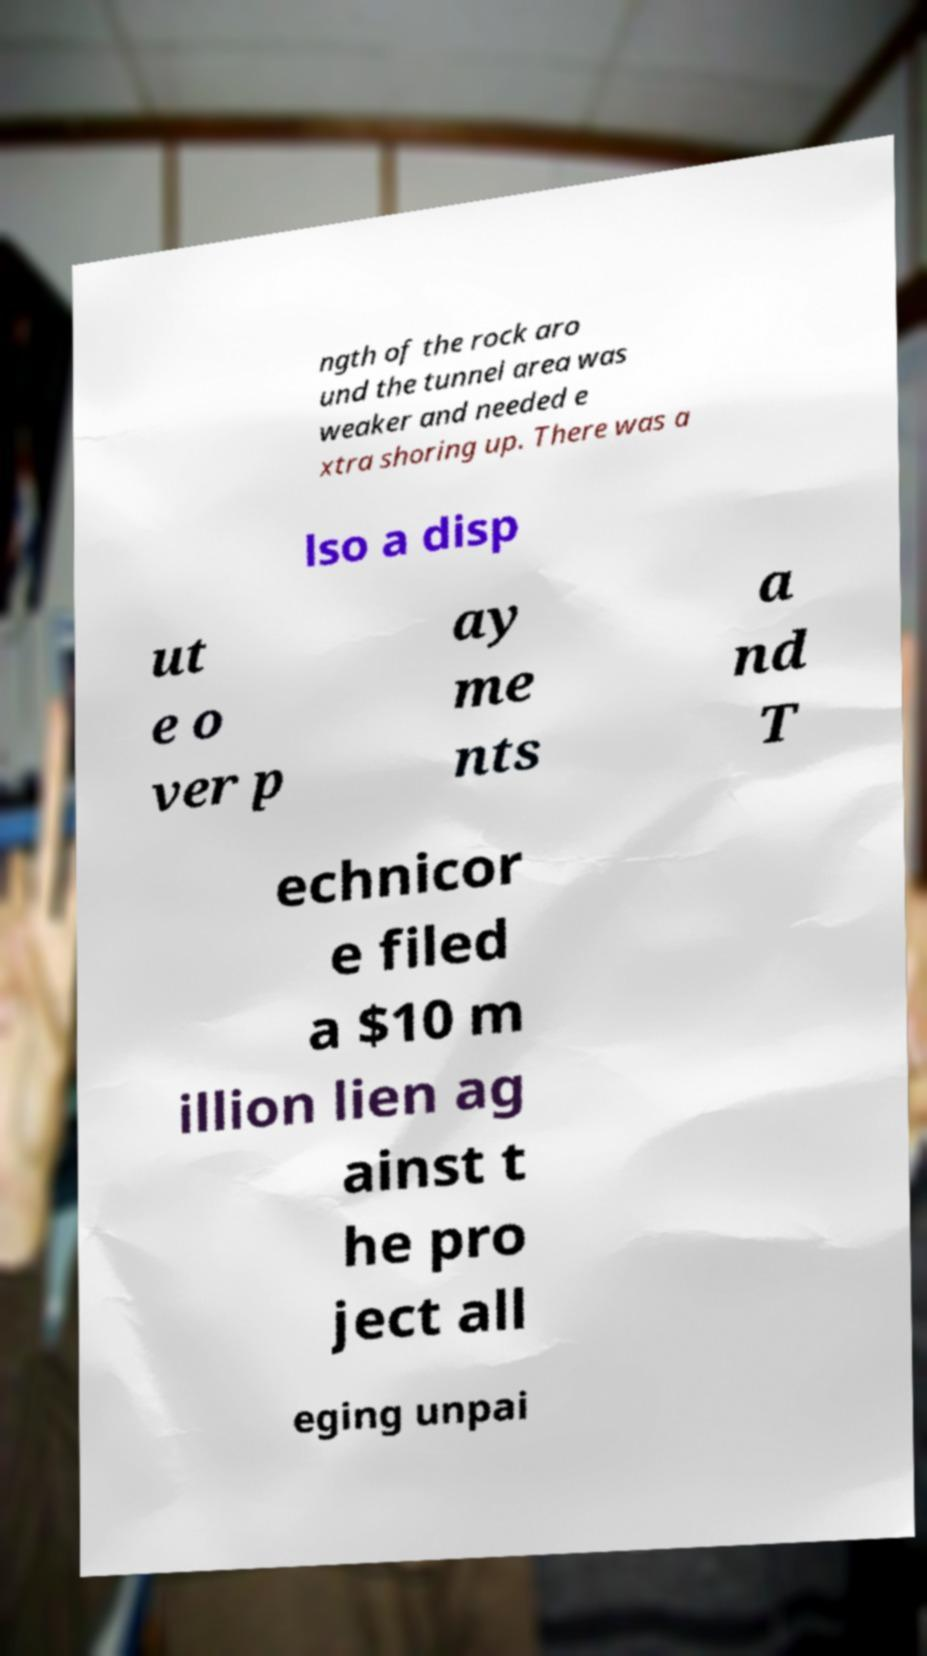Could you assist in decoding the text presented in this image and type it out clearly? ngth of the rock aro und the tunnel area was weaker and needed e xtra shoring up. There was a lso a disp ut e o ver p ay me nts a nd T echnicor e filed a $10 m illion lien ag ainst t he pro ject all eging unpai 